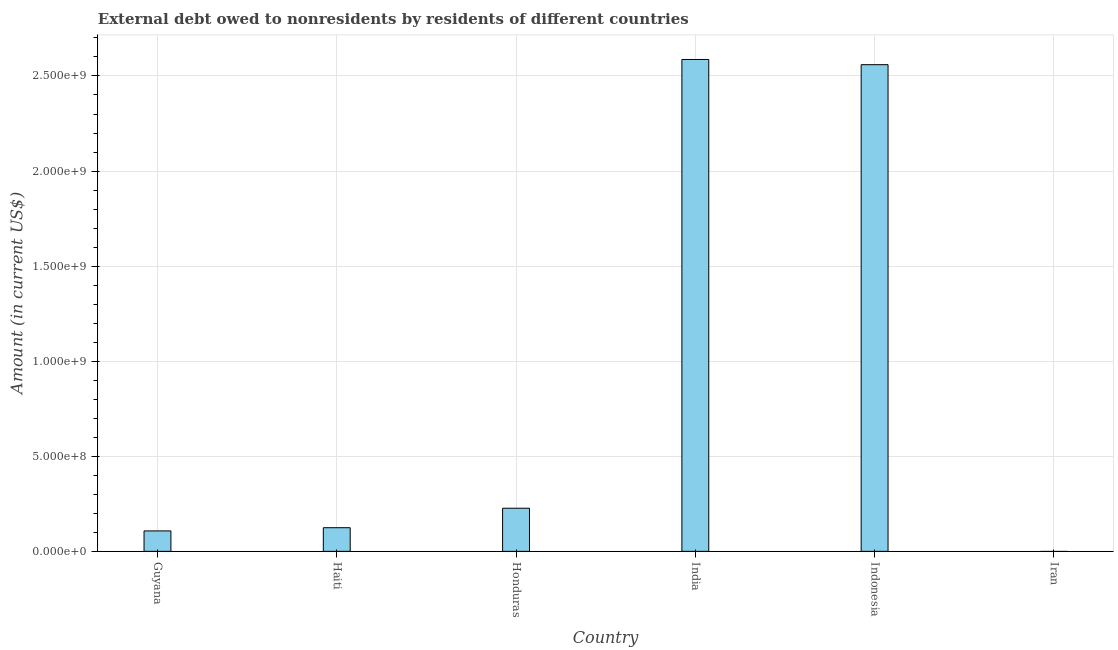What is the title of the graph?
Give a very brief answer. External debt owed to nonresidents by residents of different countries. What is the label or title of the Y-axis?
Your answer should be compact. Amount (in current US$). What is the debt in Guyana?
Provide a short and direct response. 1.07e+08. Across all countries, what is the maximum debt?
Give a very brief answer. 2.59e+09. Across all countries, what is the minimum debt?
Your answer should be compact. 0. What is the sum of the debt?
Ensure brevity in your answer.  5.61e+09. What is the difference between the debt in Honduras and India?
Your response must be concise. -2.36e+09. What is the average debt per country?
Provide a succinct answer. 9.34e+08. What is the median debt?
Provide a succinct answer. 1.76e+08. In how many countries, is the debt greater than 200000000 US$?
Provide a succinct answer. 3. Is the debt in Guyana less than that in Haiti?
Keep it short and to the point. Yes. What is the difference between the highest and the second highest debt?
Ensure brevity in your answer.  2.74e+07. What is the difference between the highest and the lowest debt?
Give a very brief answer. 2.59e+09. In how many countries, is the debt greater than the average debt taken over all countries?
Make the answer very short. 2. Are the values on the major ticks of Y-axis written in scientific E-notation?
Provide a succinct answer. Yes. What is the Amount (in current US$) in Guyana?
Your response must be concise. 1.07e+08. What is the Amount (in current US$) in Haiti?
Give a very brief answer. 1.24e+08. What is the Amount (in current US$) of Honduras?
Offer a very short reply. 2.27e+08. What is the Amount (in current US$) of India?
Make the answer very short. 2.59e+09. What is the Amount (in current US$) in Indonesia?
Offer a terse response. 2.56e+09. What is the Amount (in current US$) of Iran?
Make the answer very short. 0. What is the difference between the Amount (in current US$) in Guyana and Haiti?
Provide a short and direct response. -1.69e+07. What is the difference between the Amount (in current US$) in Guyana and Honduras?
Ensure brevity in your answer.  -1.19e+08. What is the difference between the Amount (in current US$) in Guyana and India?
Give a very brief answer. -2.48e+09. What is the difference between the Amount (in current US$) in Guyana and Indonesia?
Make the answer very short. -2.45e+09. What is the difference between the Amount (in current US$) in Haiti and Honduras?
Offer a terse response. -1.02e+08. What is the difference between the Amount (in current US$) in Haiti and India?
Make the answer very short. -2.46e+09. What is the difference between the Amount (in current US$) in Haiti and Indonesia?
Your answer should be very brief. -2.44e+09. What is the difference between the Amount (in current US$) in Honduras and India?
Your response must be concise. -2.36e+09. What is the difference between the Amount (in current US$) in Honduras and Indonesia?
Offer a terse response. -2.33e+09. What is the difference between the Amount (in current US$) in India and Indonesia?
Make the answer very short. 2.74e+07. What is the ratio of the Amount (in current US$) in Guyana to that in Haiti?
Make the answer very short. 0.86. What is the ratio of the Amount (in current US$) in Guyana to that in Honduras?
Provide a succinct answer. 0.47. What is the ratio of the Amount (in current US$) in Guyana to that in India?
Offer a very short reply. 0.04. What is the ratio of the Amount (in current US$) in Guyana to that in Indonesia?
Provide a short and direct response. 0.04. What is the ratio of the Amount (in current US$) in Haiti to that in Honduras?
Ensure brevity in your answer.  0.55. What is the ratio of the Amount (in current US$) in Haiti to that in India?
Ensure brevity in your answer.  0.05. What is the ratio of the Amount (in current US$) in Haiti to that in Indonesia?
Your response must be concise. 0.05. What is the ratio of the Amount (in current US$) in Honduras to that in India?
Provide a succinct answer. 0.09. What is the ratio of the Amount (in current US$) in Honduras to that in Indonesia?
Offer a very short reply. 0.09. 